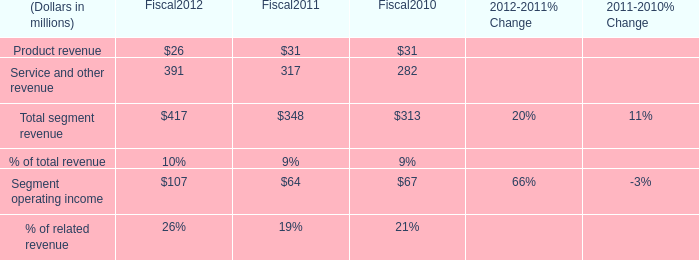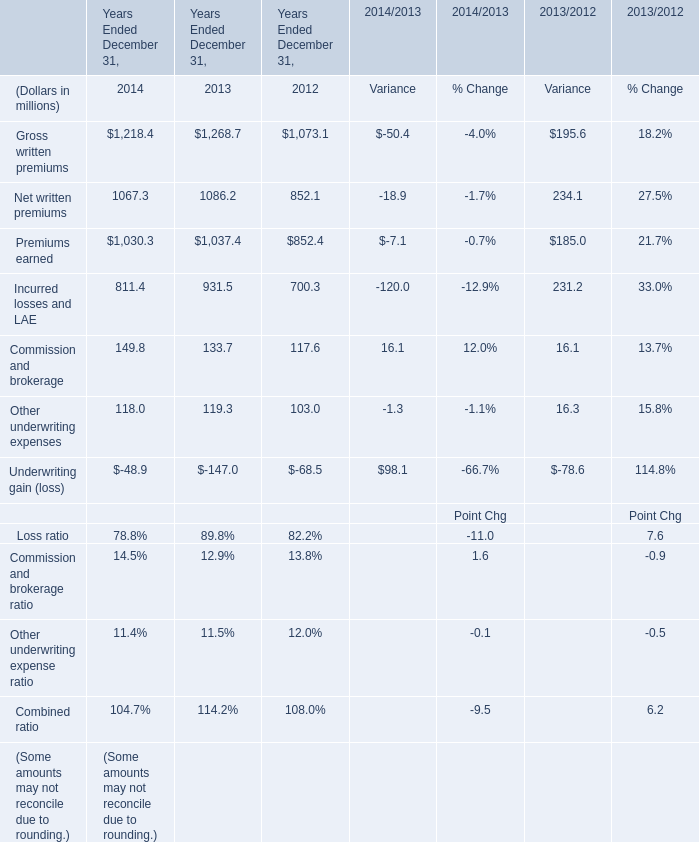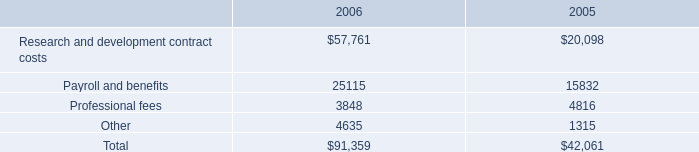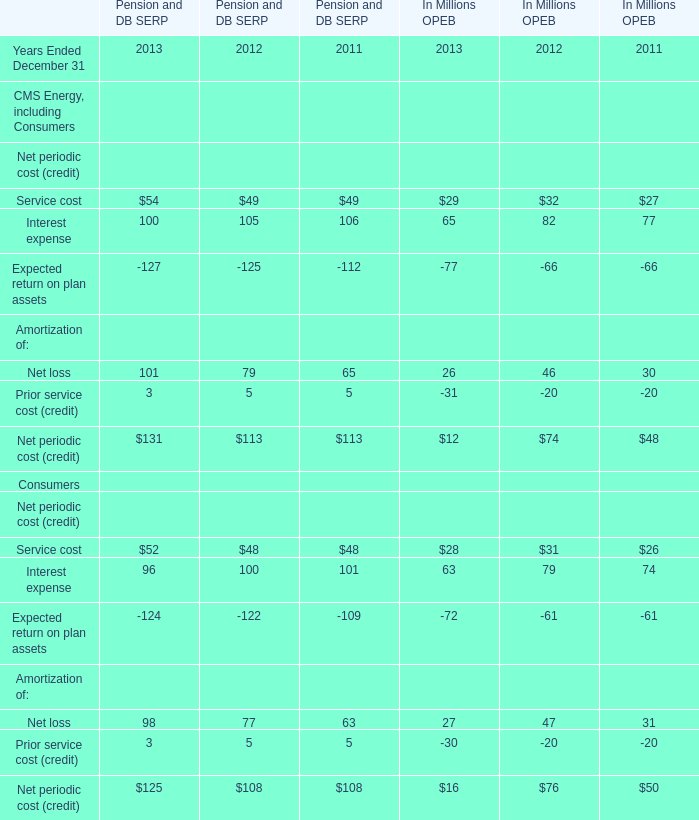What is the difference between 2012 and 2013 's highest service cost in net periodic cost (credit) for OPEB? (in million) 
Computations: (29 - 32)
Answer: -3.0. 